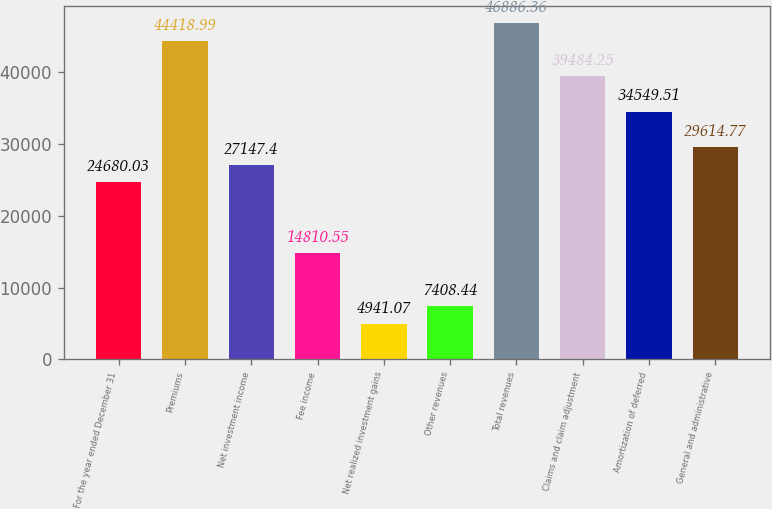<chart> <loc_0><loc_0><loc_500><loc_500><bar_chart><fcel>For the year ended December 31<fcel>Premiums<fcel>Net investment income<fcel>Fee income<fcel>Net realized investment gains<fcel>Other revenues<fcel>Total revenues<fcel>Claims and claim adjustment<fcel>Amortization of deferred<fcel>General and administrative<nl><fcel>24680<fcel>44419<fcel>27147.4<fcel>14810.5<fcel>4941.07<fcel>7408.44<fcel>46886.4<fcel>39484.2<fcel>34549.5<fcel>29614.8<nl></chart> 